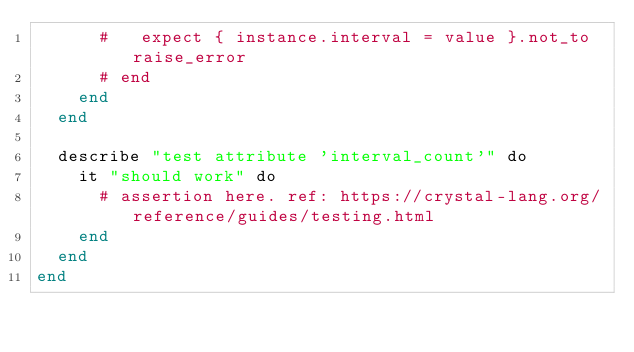<code> <loc_0><loc_0><loc_500><loc_500><_Crystal_>      #   expect { instance.interval = value }.not_to raise_error
      # end
    end
  end

  describe "test attribute 'interval_count'" do
    it "should work" do
      # assertion here. ref: https://crystal-lang.org/reference/guides/testing.html
    end
  end
end
</code> 